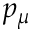Convert formula to latex. <formula><loc_0><loc_0><loc_500><loc_500>p _ { \mu }</formula> 